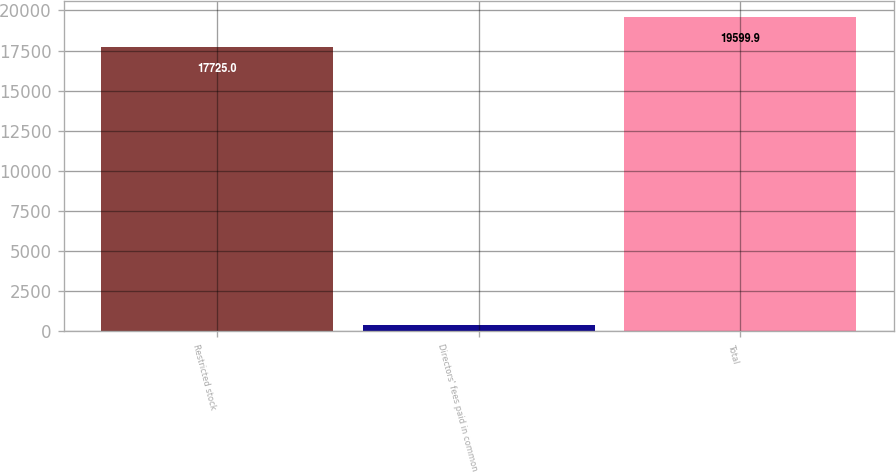<chart> <loc_0><loc_0><loc_500><loc_500><bar_chart><fcel>Restricted stock<fcel>Directors' fees paid in common<fcel>Total<nl><fcel>17725<fcel>389<fcel>19599.9<nl></chart> 